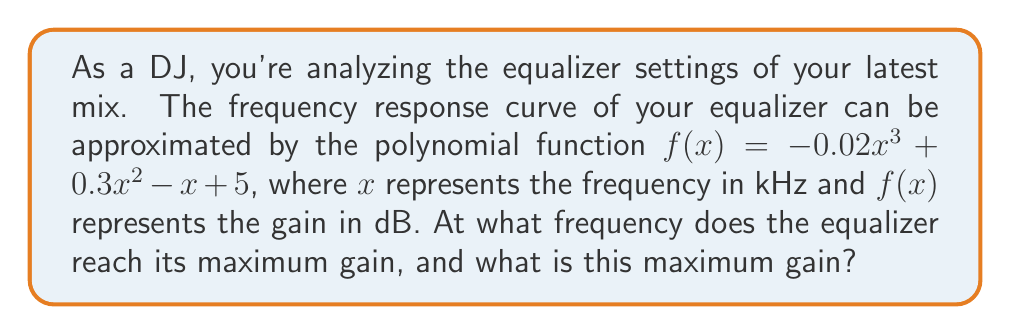What is the answer to this math problem? To find the maximum gain and the corresponding frequency, we need to follow these steps:

1) First, we need to find the derivative of the function:
   $$f'(x) = -0.06x^2 + 0.6x - 1$$

2) To find the critical points, set $f'(x) = 0$:
   $$-0.06x^2 + 0.6x - 1 = 0$$

3) This is a quadratic equation. We can solve it using the quadratic formula:
   $$x = \frac{-b \pm \sqrt{b^2 - 4ac}}{2a}$$
   where $a = -0.06$, $b = 0.6$, and $c = -1$

4) Plugging in these values:
   $$x = \frac{-0.6 \pm \sqrt{0.6^2 - 4(-0.06)(-1)}}{2(-0.06)}$$
   $$= \frac{-0.6 \pm \sqrt{0.36 - 0.24}}{-0.12}$$
   $$= \frac{-0.6 \pm \sqrt{0.12}}{-0.12}$$
   $$= \frac{-0.6 \pm 0.3464}{-0.12}$$

5) This gives us two solutions:
   $$x_1 = \frac{-0.6 + 0.3464}{-0.12} \approx 2.11$$
   $$x_2 = \frac{-0.6 - 0.3464}{-0.12} \approx 7.89$$

6) To determine which of these is the maximum, we can check the second derivative:
   $$f''(x) = -0.12x + 0.6$$
   At $x = 2.11$, $f''(2.11) = -0.2532 < 0$, indicating a maximum.
   At $x = 7.89$, $f''(7.89) = -0.3468 < 0$, indicating a maximum.

7) Since both critical points are maxima, we need to evaluate $f(x)$ at both points to find the global maximum:
   $$f(2.11) \approx 5.742$$
   $$f(7.89) \approx 3.258$$

Therefore, the maximum gain occurs at $x \approx 2.11$ kHz with a gain of approximately 5.742 dB.
Answer: Frequency: 2.11 kHz; Maximum gain: 5.742 dB 